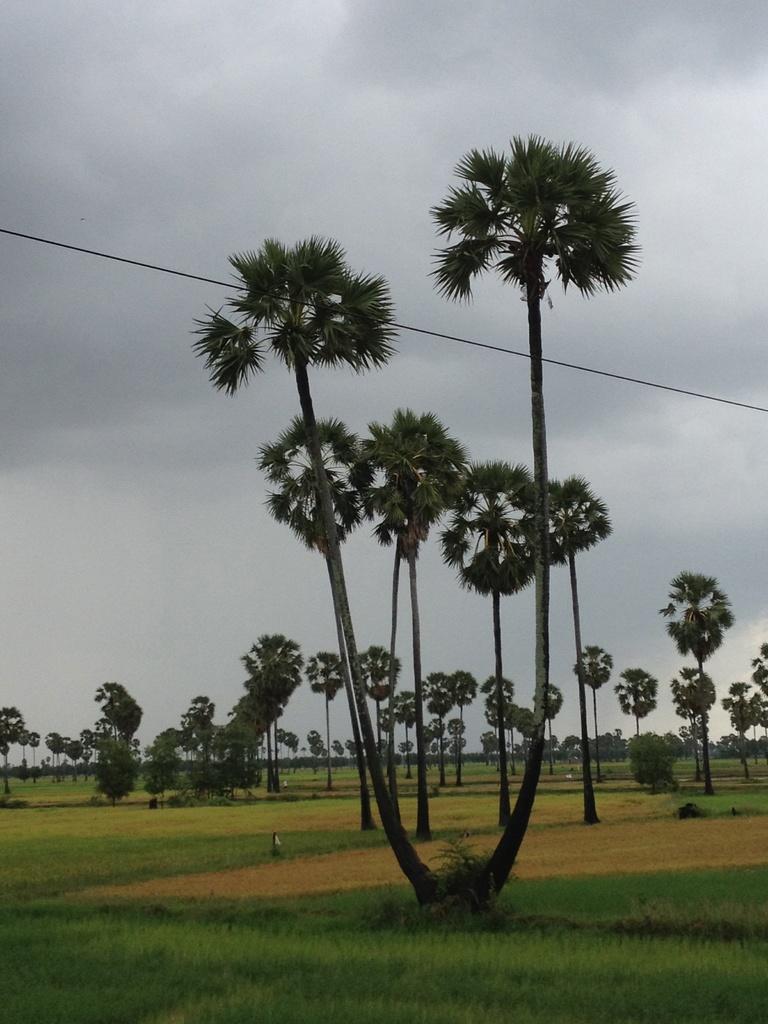Can you describe this image briefly? In this image there is a farm at the bottom. In the middle there are tall palm trees. At the top there is a wire. In the background there are so many fields. At the top there is the sky. 